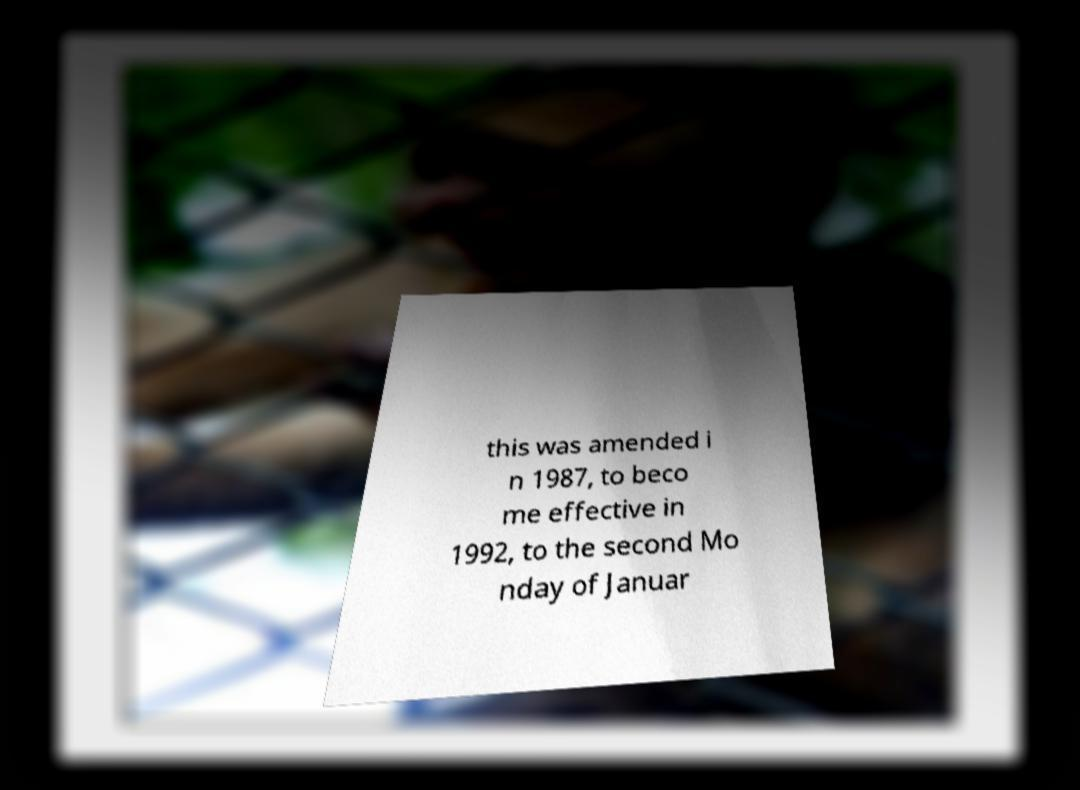Can you accurately transcribe the text from the provided image for me? this was amended i n 1987, to beco me effective in 1992, to the second Mo nday of Januar 